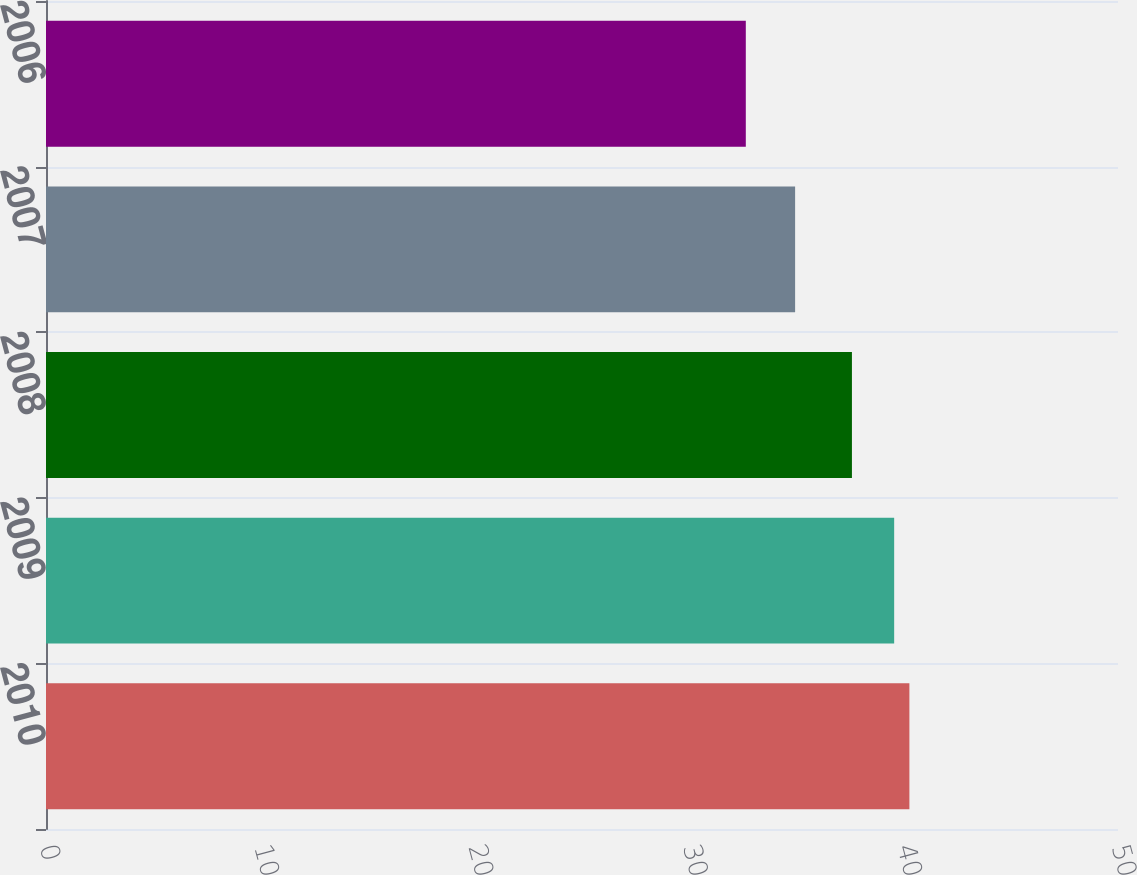<chart> <loc_0><loc_0><loc_500><loc_500><bar_chart><fcel>2010<fcel>2009<fcel>2008<fcel>2007<fcel>2006<nl><fcel>40.27<fcel>39.56<fcel>37.59<fcel>34.94<fcel>32.64<nl></chart> 